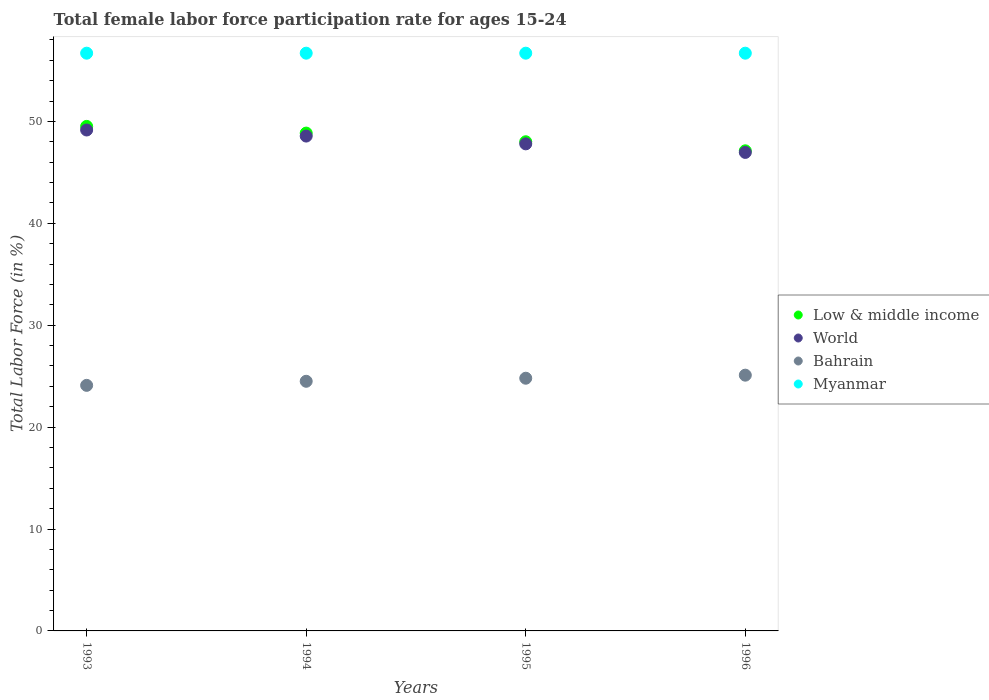Is the number of dotlines equal to the number of legend labels?
Give a very brief answer. Yes. What is the female labor force participation rate in Low & middle income in 1996?
Provide a succinct answer. 47.12. Across all years, what is the maximum female labor force participation rate in Low & middle income?
Give a very brief answer. 49.51. Across all years, what is the minimum female labor force participation rate in Low & middle income?
Offer a very short reply. 47.12. In which year was the female labor force participation rate in Low & middle income maximum?
Your answer should be compact. 1993. What is the total female labor force participation rate in Low & middle income in the graph?
Keep it short and to the point. 193.5. What is the difference between the female labor force participation rate in Myanmar in 1993 and that in 1995?
Your answer should be compact. 0. What is the difference between the female labor force participation rate in Bahrain in 1994 and the female labor force participation rate in World in 1996?
Your answer should be compact. -22.46. What is the average female labor force participation rate in Myanmar per year?
Keep it short and to the point. 56.7. In the year 1995, what is the difference between the female labor force participation rate in Myanmar and female labor force participation rate in Low & middle income?
Provide a short and direct response. 8.69. What is the ratio of the female labor force participation rate in Myanmar in 1993 to that in 1994?
Offer a very short reply. 1. Is the female labor force participation rate in Bahrain in 1993 less than that in 1996?
Make the answer very short. Yes. Is the difference between the female labor force participation rate in Myanmar in 1993 and 1994 greater than the difference between the female labor force participation rate in Low & middle income in 1993 and 1994?
Provide a succinct answer. No. What is the difference between the highest and the second highest female labor force participation rate in Low & middle income?
Keep it short and to the point. 0.66. What is the difference between the highest and the lowest female labor force participation rate in Myanmar?
Give a very brief answer. 0. Is it the case that in every year, the sum of the female labor force participation rate in Bahrain and female labor force participation rate in Low & middle income  is greater than the female labor force participation rate in Myanmar?
Your answer should be compact. Yes. Is the female labor force participation rate in Bahrain strictly greater than the female labor force participation rate in World over the years?
Your response must be concise. No. How many dotlines are there?
Your response must be concise. 4. How many years are there in the graph?
Make the answer very short. 4. What is the difference between two consecutive major ticks on the Y-axis?
Provide a short and direct response. 10. Where does the legend appear in the graph?
Keep it short and to the point. Center right. What is the title of the graph?
Make the answer very short. Total female labor force participation rate for ages 15-24. Does "Sweden" appear as one of the legend labels in the graph?
Make the answer very short. No. What is the label or title of the X-axis?
Your answer should be very brief. Years. What is the label or title of the Y-axis?
Keep it short and to the point. Total Labor Force (in %). What is the Total Labor Force (in %) in Low & middle income in 1993?
Your response must be concise. 49.51. What is the Total Labor Force (in %) of World in 1993?
Provide a short and direct response. 49.16. What is the Total Labor Force (in %) of Bahrain in 1993?
Give a very brief answer. 24.1. What is the Total Labor Force (in %) in Myanmar in 1993?
Provide a succinct answer. 56.7. What is the Total Labor Force (in %) in Low & middle income in 1994?
Offer a terse response. 48.86. What is the Total Labor Force (in %) of World in 1994?
Your answer should be compact. 48.57. What is the Total Labor Force (in %) of Bahrain in 1994?
Provide a succinct answer. 24.5. What is the Total Labor Force (in %) in Myanmar in 1994?
Make the answer very short. 56.7. What is the Total Labor Force (in %) of Low & middle income in 1995?
Offer a very short reply. 48.01. What is the Total Labor Force (in %) of World in 1995?
Your response must be concise. 47.8. What is the Total Labor Force (in %) of Bahrain in 1995?
Ensure brevity in your answer.  24.8. What is the Total Labor Force (in %) of Myanmar in 1995?
Keep it short and to the point. 56.7. What is the Total Labor Force (in %) of Low & middle income in 1996?
Your answer should be compact. 47.12. What is the Total Labor Force (in %) in World in 1996?
Provide a succinct answer. 46.96. What is the Total Labor Force (in %) of Bahrain in 1996?
Make the answer very short. 25.1. What is the Total Labor Force (in %) in Myanmar in 1996?
Offer a terse response. 56.7. Across all years, what is the maximum Total Labor Force (in %) of Low & middle income?
Offer a terse response. 49.51. Across all years, what is the maximum Total Labor Force (in %) in World?
Your answer should be very brief. 49.16. Across all years, what is the maximum Total Labor Force (in %) in Bahrain?
Your response must be concise. 25.1. Across all years, what is the maximum Total Labor Force (in %) in Myanmar?
Give a very brief answer. 56.7. Across all years, what is the minimum Total Labor Force (in %) of Low & middle income?
Keep it short and to the point. 47.12. Across all years, what is the minimum Total Labor Force (in %) of World?
Your answer should be very brief. 46.96. Across all years, what is the minimum Total Labor Force (in %) of Bahrain?
Your answer should be very brief. 24.1. Across all years, what is the minimum Total Labor Force (in %) in Myanmar?
Offer a very short reply. 56.7. What is the total Total Labor Force (in %) in Low & middle income in the graph?
Make the answer very short. 193.5. What is the total Total Labor Force (in %) in World in the graph?
Your answer should be compact. 192.49. What is the total Total Labor Force (in %) of Bahrain in the graph?
Your answer should be compact. 98.5. What is the total Total Labor Force (in %) of Myanmar in the graph?
Provide a succinct answer. 226.8. What is the difference between the Total Labor Force (in %) of Low & middle income in 1993 and that in 1994?
Offer a very short reply. 0.66. What is the difference between the Total Labor Force (in %) in World in 1993 and that in 1994?
Keep it short and to the point. 0.6. What is the difference between the Total Labor Force (in %) in Bahrain in 1993 and that in 1994?
Offer a terse response. -0.4. What is the difference between the Total Labor Force (in %) in Low & middle income in 1993 and that in 1995?
Give a very brief answer. 1.51. What is the difference between the Total Labor Force (in %) of World in 1993 and that in 1995?
Give a very brief answer. 1.36. What is the difference between the Total Labor Force (in %) in Low & middle income in 1993 and that in 1996?
Ensure brevity in your answer.  2.4. What is the difference between the Total Labor Force (in %) of World in 1993 and that in 1996?
Ensure brevity in your answer.  2.2. What is the difference between the Total Labor Force (in %) of Low & middle income in 1994 and that in 1995?
Provide a short and direct response. 0.85. What is the difference between the Total Labor Force (in %) of World in 1994 and that in 1995?
Offer a very short reply. 0.76. What is the difference between the Total Labor Force (in %) of Bahrain in 1994 and that in 1995?
Make the answer very short. -0.3. What is the difference between the Total Labor Force (in %) of Myanmar in 1994 and that in 1995?
Give a very brief answer. 0. What is the difference between the Total Labor Force (in %) in Low & middle income in 1994 and that in 1996?
Offer a terse response. 1.74. What is the difference between the Total Labor Force (in %) of World in 1994 and that in 1996?
Your response must be concise. 1.6. What is the difference between the Total Labor Force (in %) of Myanmar in 1994 and that in 1996?
Your answer should be very brief. 0. What is the difference between the Total Labor Force (in %) of Low & middle income in 1995 and that in 1996?
Offer a terse response. 0.89. What is the difference between the Total Labor Force (in %) in World in 1995 and that in 1996?
Your answer should be compact. 0.84. What is the difference between the Total Labor Force (in %) of Bahrain in 1995 and that in 1996?
Provide a succinct answer. -0.3. What is the difference between the Total Labor Force (in %) of Low & middle income in 1993 and the Total Labor Force (in %) of World in 1994?
Provide a short and direct response. 0.95. What is the difference between the Total Labor Force (in %) in Low & middle income in 1993 and the Total Labor Force (in %) in Bahrain in 1994?
Offer a terse response. 25.02. What is the difference between the Total Labor Force (in %) in Low & middle income in 1993 and the Total Labor Force (in %) in Myanmar in 1994?
Keep it short and to the point. -7.18. What is the difference between the Total Labor Force (in %) of World in 1993 and the Total Labor Force (in %) of Bahrain in 1994?
Make the answer very short. 24.66. What is the difference between the Total Labor Force (in %) in World in 1993 and the Total Labor Force (in %) in Myanmar in 1994?
Provide a succinct answer. -7.54. What is the difference between the Total Labor Force (in %) in Bahrain in 1993 and the Total Labor Force (in %) in Myanmar in 1994?
Your response must be concise. -32.6. What is the difference between the Total Labor Force (in %) of Low & middle income in 1993 and the Total Labor Force (in %) of World in 1995?
Ensure brevity in your answer.  1.71. What is the difference between the Total Labor Force (in %) in Low & middle income in 1993 and the Total Labor Force (in %) in Bahrain in 1995?
Your answer should be very brief. 24.71. What is the difference between the Total Labor Force (in %) of Low & middle income in 1993 and the Total Labor Force (in %) of Myanmar in 1995?
Offer a terse response. -7.18. What is the difference between the Total Labor Force (in %) of World in 1993 and the Total Labor Force (in %) of Bahrain in 1995?
Your answer should be compact. 24.36. What is the difference between the Total Labor Force (in %) in World in 1993 and the Total Labor Force (in %) in Myanmar in 1995?
Your answer should be very brief. -7.54. What is the difference between the Total Labor Force (in %) in Bahrain in 1993 and the Total Labor Force (in %) in Myanmar in 1995?
Offer a terse response. -32.6. What is the difference between the Total Labor Force (in %) in Low & middle income in 1993 and the Total Labor Force (in %) in World in 1996?
Offer a very short reply. 2.55. What is the difference between the Total Labor Force (in %) of Low & middle income in 1993 and the Total Labor Force (in %) of Bahrain in 1996?
Keep it short and to the point. 24.41. What is the difference between the Total Labor Force (in %) of Low & middle income in 1993 and the Total Labor Force (in %) of Myanmar in 1996?
Your response must be concise. -7.18. What is the difference between the Total Labor Force (in %) in World in 1993 and the Total Labor Force (in %) in Bahrain in 1996?
Provide a succinct answer. 24.06. What is the difference between the Total Labor Force (in %) in World in 1993 and the Total Labor Force (in %) in Myanmar in 1996?
Your answer should be compact. -7.54. What is the difference between the Total Labor Force (in %) of Bahrain in 1993 and the Total Labor Force (in %) of Myanmar in 1996?
Offer a terse response. -32.6. What is the difference between the Total Labor Force (in %) of Low & middle income in 1994 and the Total Labor Force (in %) of World in 1995?
Provide a short and direct response. 1.06. What is the difference between the Total Labor Force (in %) of Low & middle income in 1994 and the Total Labor Force (in %) of Bahrain in 1995?
Make the answer very short. 24.06. What is the difference between the Total Labor Force (in %) in Low & middle income in 1994 and the Total Labor Force (in %) in Myanmar in 1995?
Your answer should be compact. -7.84. What is the difference between the Total Labor Force (in %) of World in 1994 and the Total Labor Force (in %) of Bahrain in 1995?
Offer a terse response. 23.77. What is the difference between the Total Labor Force (in %) in World in 1994 and the Total Labor Force (in %) in Myanmar in 1995?
Your answer should be compact. -8.13. What is the difference between the Total Labor Force (in %) of Bahrain in 1994 and the Total Labor Force (in %) of Myanmar in 1995?
Provide a short and direct response. -32.2. What is the difference between the Total Labor Force (in %) in Low & middle income in 1994 and the Total Labor Force (in %) in World in 1996?
Offer a very short reply. 1.9. What is the difference between the Total Labor Force (in %) of Low & middle income in 1994 and the Total Labor Force (in %) of Bahrain in 1996?
Provide a succinct answer. 23.76. What is the difference between the Total Labor Force (in %) of Low & middle income in 1994 and the Total Labor Force (in %) of Myanmar in 1996?
Give a very brief answer. -7.84. What is the difference between the Total Labor Force (in %) in World in 1994 and the Total Labor Force (in %) in Bahrain in 1996?
Give a very brief answer. 23.47. What is the difference between the Total Labor Force (in %) in World in 1994 and the Total Labor Force (in %) in Myanmar in 1996?
Offer a very short reply. -8.13. What is the difference between the Total Labor Force (in %) of Bahrain in 1994 and the Total Labor Force (in %) of Myanmar in 1996?
Your answer should be very brief. -32.2. What is the difference between the Total Labor Force (in %) in Low & middle income in 1995 and the Total Labor Force (in %) in World in 1996?
Make the answer very short. 1.05. What is the difference between the Total Labor Force (in %) of Low & middle income in 1995 and the Total Labor Force (in %) of Bahrain in 1996?
Keep it short and to the point. 22.91. What is the difference between the Total Labor Force (in %) in Low & middle income in 1995 and the Total Labor Force (in %) in Myanmar in 1996?
Your answer should be very brief. -8.69. What is the difference between the Total Labor Force (in %) in World in 1995 and the Total Labor Force (in %) in Bahrain in 1996?
Provide a succinct answer. 22.7. What is the difference between the Total Labor Force (in %) in World in 1995 and the Total Labor Force (in %) in Myanmar in 1996?
Your response must be concise. -8.9. What is the difference between the Total Labor Force (in %) in Bahrain in 1995 and the Total Labor Force (in %) in Myanmar in 1996?
Provide a succinct answer. -31.9. What is the average Total Labor Force (in %) of Low & middle income per year?
Your response must be concise. 48.37. What is the average Total Labor Force (in %) in World per year?
Keep it short and to the point. 48.12. What is the average Total Labor Force (in %) in Bahrain per year?
Ensure brevity in your answer.  24.62. What is the average Total Labor Force (in %) in Myanmar per year?
Provide a succinct answer. 56.7. In the year 1993, what is the difference between the Total Labor Force (in %) in Low & middle income and Total Labor Force (in %) in World?
Keep it short and to the point. 0.35. In the year 1993, what is the difference between the Total Labor Force (in %) in Low & middle income and Total Labor Force (in %) in Bahrain?
Make the answer very short. 25.41. In the year 1993, what is the difference between the Total Labor Force (in %) of Low & middle income and Total Labor Force (in %) of Myanmar?
Offer a terse response. -7.18. In the year 1993, what is the difference between the Total Labor Force (in %) in World and Total Labor Force (in %) in Bahrain?
Give a very brief answer. 25.06. In the year 1993, what is the difference between the Total Labor Force (in %) in World and Total Labor Force (in %) in Myanmar?
Offer a very short reply. -7.54. In the year 1993, what is the difference between the Total Labor Force (in %) in Bahrain and Total Labor Force (in %) in Myanmar?
Make the answer very short. -32.6. In the year 1994, what is the difference between the Total Labor Force (in %) of Low & middle income and Total Labor Force (in %) of World?
Give a very brief answer. 0.29. In the year 1994, what is the difference between the Total Labor Force (in %) of Low & middle income and Total Labor Force (in %) of Bahrain?
Make the answer very short. 24.36. In the year 1994, what is the difference between the Total Labor Force (in %) in Low & middle income and Total Labor Force (in %) in Myanmar?
Provide a succinct answer. -7.84. In the year 1994, what is the difference between the Total Labor Force (in %) of World and Total Labor Force (in %) of Bahrain?
Offer a terse response. 24.07. In the year 1994, what is the difference between the Total Labor Force (in %) of World and Total Labor Force (in %) of Myanmar?
Provide a short and direct response. -8.13. In the year 1994, what is the difference between the Total Labor Force (in %) of Bahrain and Total Labor Force (in %) of Myanmar?
Your answer should be compact. -32.2. In the year 1995, what is the difference between the Total Labor Force (in %) of Low & middle income and Total Labor Force (in %) of World?
Your answer should be compact. 0.21. In the year 1995, what is the difference between the Total Labor Force (in %) of Low & middle income and Total Labor Force (in %) of Bahrain?
Keep it short and to the point. 23.21. In the year 1995, what is the difference between the Total Labor Force (in %) of Low & middle income and Total Labor Force (in %) of Myanmar?
Provide a succinct answer. -8.69. In the year 1995, what is the difference between the Total Labor Force (in %) of World and Total Labor Force (in %) of Bahrain?
Provide a succinct answer. 23. In the year 1995, what is the difference between the Total Labor Force (in %) of World and Total Labor Force (in %) of Myanmar?
Keep it short and to the point. -8.9. In the year 1995, what is the difference between the Total Labor Force (in %) in Bahrain and Total Labor Force (in %) in Myanmar?
Your answer should be very brief. -31.9. In the year 1996, what is the difference between the Total Labor Force (in %) of Low & middle income and Total Labor Force (in %) of World?
Give a very brief answer. 0.16. In the year 1996, what is the difference between the Total Labor Force (in %) in Low & middle income and Total Labor Force (in %) in Bahrain?
Make the answer very short. 22.02. In the year 1996, what is the difference between the Total Labor Force (in %) in Low & middle income and Total Labor Force (in %) in Myanmar?
Provide a short and direct response. -9.58. In the year 1996, what is the difference between the Total Labor Force (in %) in World and Total Labor Force (in %) in Bahrain?
Your answer should be very brief. 21.86. In the year 1996, what is the difference between the Total Labor Force (in %) of World and Total Labor Force (in %) of Myanmar?
Offer a very short reply. -9.74. In the year 1996, what is the difference between the Total Labor Force (in %) in Bahrain and Total Labor Force (in %) in Myanmar?
Provide a short and direct response. -31.6. What is the ratio of the Total Labor Force (in %) in Low & middle income in 1993 to that in 1994?
Provide a succinct answer. 1.01. What is the ratio of the Total Labor Force (in %) in World in 1993 to that in 1994?
Provide a succinct answer. 1.01. What is the ratio of the Total Labor Force (in %) in Bahrain in 1993 to that in 1994?
Provide a short and direct response. 0.98. What is the ratio of the Total Labor Force (in %) of Low & middle income in 1993 to that in 1995?
Make the answer very short. 1.03. What is the ratio of the Total Labor Force (in %) of World in 1993 to that in 1995?
Ensure brevity in your answer.  1.03. What is the ratio of the Total Labor Force (in %) in Bahrain in 1993 to that in 1995?
Provide a short and direct response. 0.97. What is the ratio of the Total Labor Force (in %) of Myanmar in 1993 to that in 1995?
Provide a succinct answer. 1. What is the ratio of the Total Labor Force (in %) in Low & middle income in 1993 to that in 1996?
Your answer should be compact. 1.05. What is the ratio of the Total Labor Force (in %) in World in 1993 to that in 1996?
Ensure brevity in your answer.  1.05. What is the ratio of the Total Labor Force (in %) of Bahrain in 1993 to that in 1996?
Your answer should be compact. 0.96. What is the ratio of the Total Labor Force (in %) in Low & middle income in 1994 to that in 1995?
Provide a succinct answer. 1.02. What is the ratio of the Total Labor Force (in %) of Bahrain in 1994 to that in 1995?
Ensure brevity in your answer.  0.99. What is the ratio of the Total Labor Force (in %) in Myanmar in 1994 to that in 1995?
Give a very brief answer. 1. What is the ratio of the Total Labor Force (in %) in Low & middle income in 1994 to that in 1996?
Provide a short and direct response. 1.04. What is the ratio of the Total Labor Force (in %) in World in 1994 to that in 1996?
Your response must be concise. 1.03. What is the ratio of the Total Labor Force (in %) of Bahrain in 1994 to that in 1996?
Provide a succinct answer. 0.98. What is the ratio of the Total Labor Force (in %) of Low & middle income in 1995 to that in 1996?
Your response must be concise. 1.02. What is the ratio of the Total Labor Force (in %) of World in 1995 to that in 1996?
Provide a succinct answer. 1.02. What is the ratio of the Total Labor Force (in %) in Bahrain in 1995 to that in 1996?
Provide a short and direct response. 0.99. What is the difference between the highest and the second highest Total Labor Force (in %) of Low & middle income?
Your answer should be compact. 0.66. What is the difference between the highest and the second highest Total Labor Force (in %) in World?
Your answer should be compact. 0.6. What is the difference between the highest and the second highest Total Labor Force (in %) of Bahrain?
Offer a very short reply. 0.3. What is the difference between the highest and the second highest Total Labor Force (in %) in Myanmar?
Your answer should be very brief. 0. What is the difference between the highest and the lowest Total Labor Force (in %) of Low & middle income?
Your response must be concise. 2.4. What is the difference between the highest and the lowest Total Labor Force (in %) in World?
Offer a terse response. 2.2. 